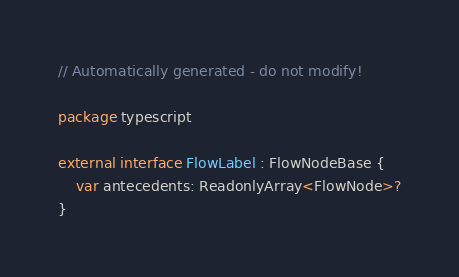<code> <loc_0><loc_0><loc_500><loc_500><_Kotlin_>// Automatically generated - do not modify!

package typescript

external interface FlowLabel : FlowNodeBase {
    var antecedents: ReadonlyArray<FlowNode>?
}
</code> 